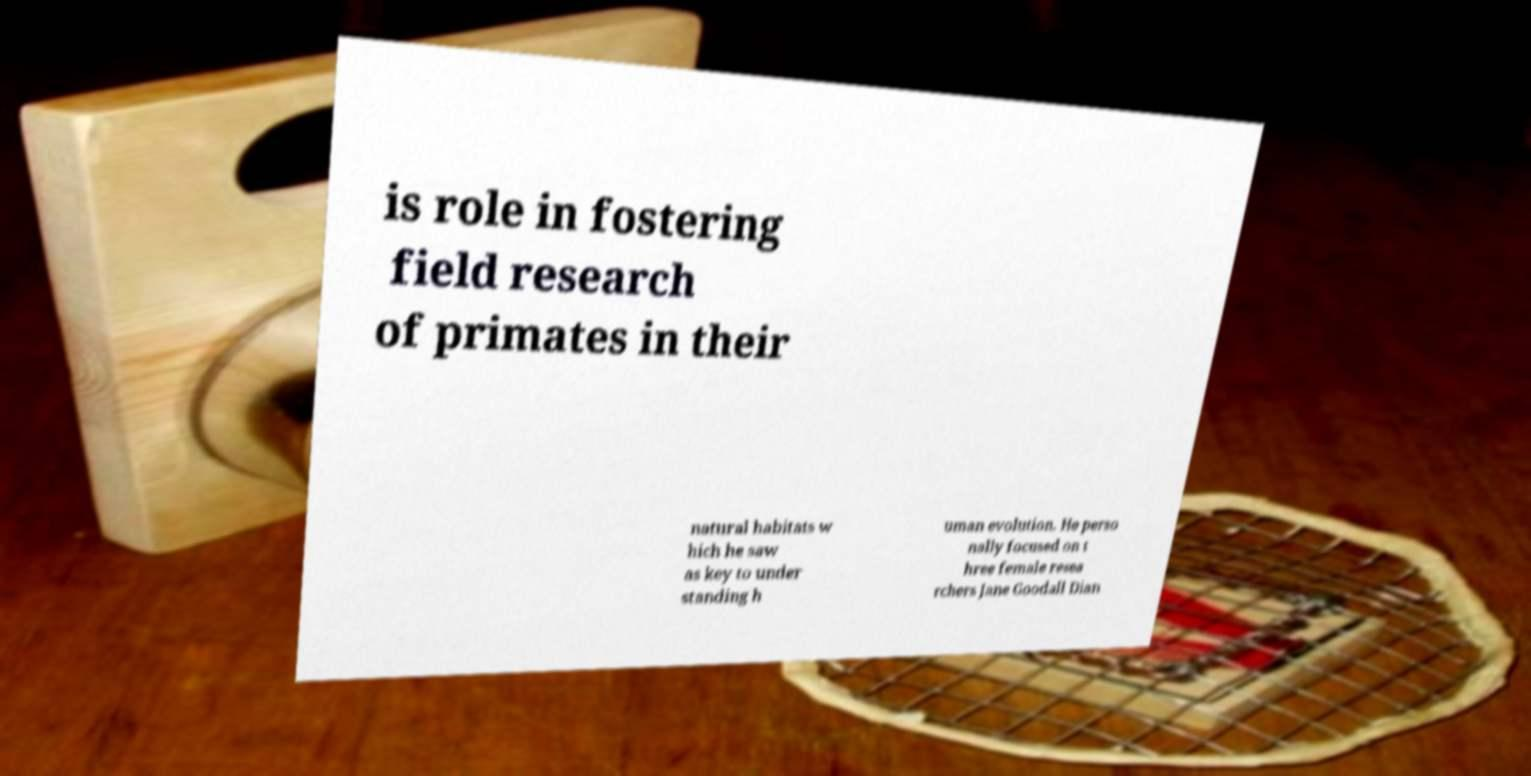There's text embedded in this image that I need extracted. Can you transcribe it verbatim? is role in fostering field research of primates in their natural habitats w hich he saw as key to under standing h uman evolution. He perso nally focused on t hree female resea rchers Jane Goodall Dian 